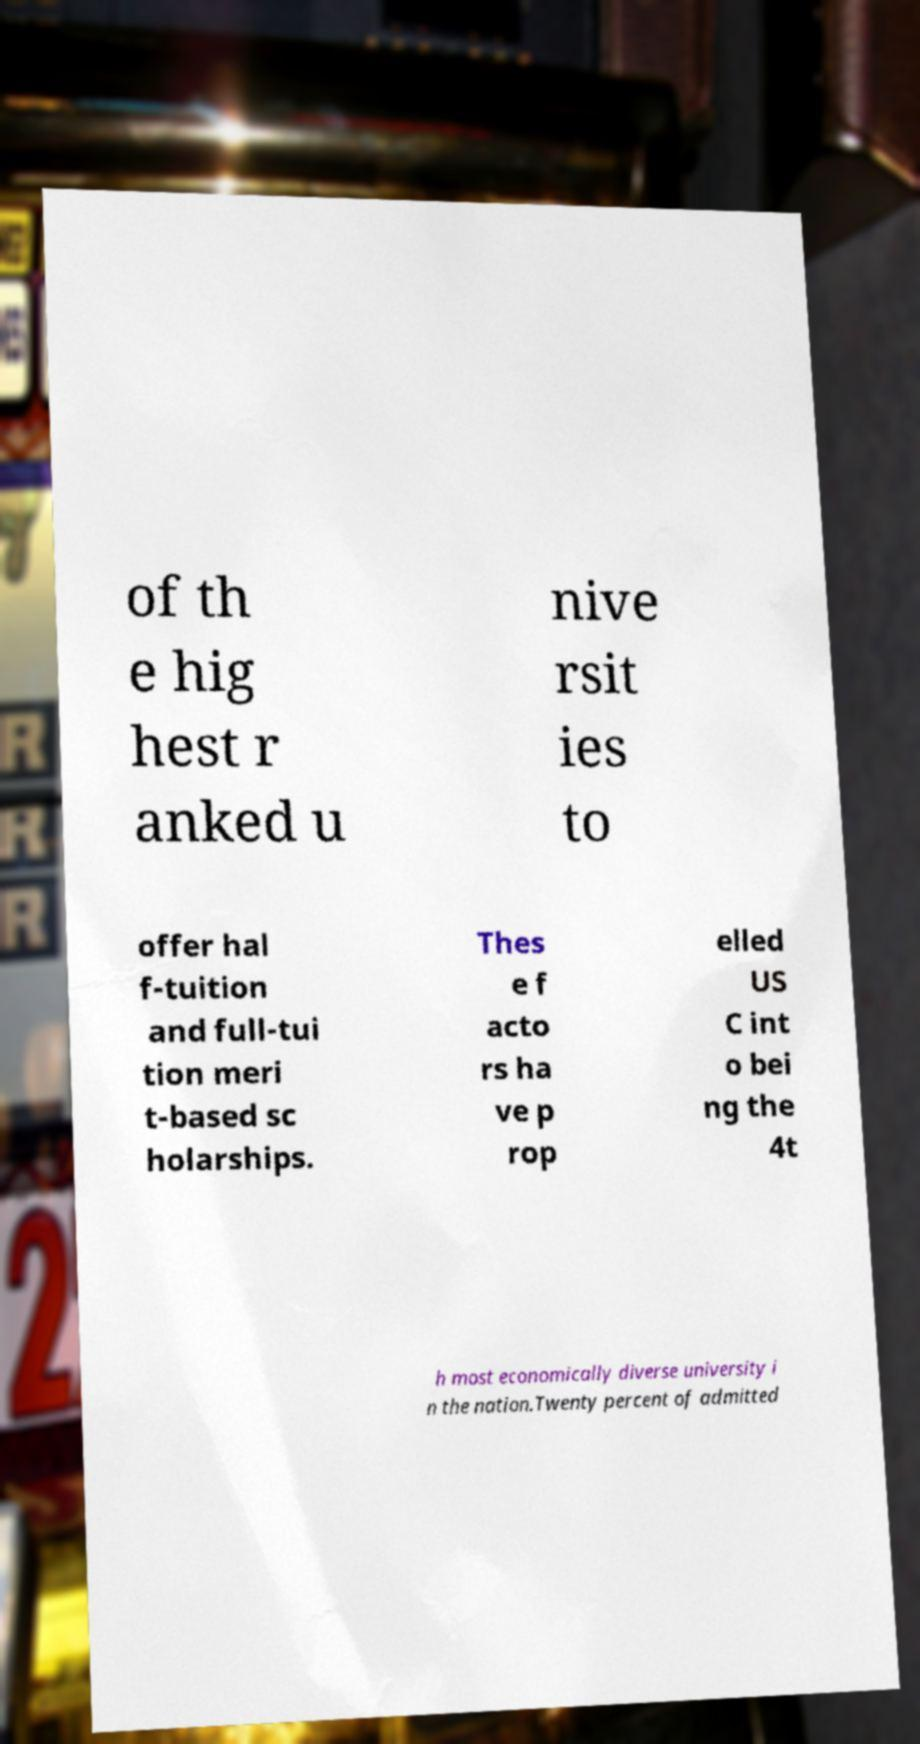Please identify and transcribe the text found in this image. of th e hig hest r anked u nive rsit ies to offer hal f-tuition and full-tui tion meri t-based sc holarships. Thes e f acto rs ha ve p rop elled US C int o bei ng the 4t h most economically diverse university i n the nation.Twenty percent of admitted 